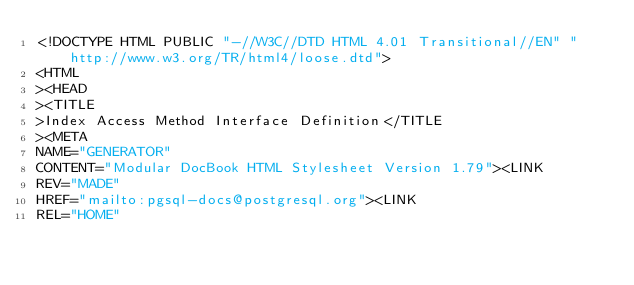<code> <loc_0><loc_0><loc_500><loc_500><_HTML_><!DOCTYPE HTML PUBLIC "-//W3C//DTD HTML 4.01 Transitional//EN" "http://www.w3.org/TR/html4/loose.dtd">
<HTML
><HEAD
><TITLE
>Index Access Method Interface Definition</TITLE
><META
NAME="GENERATOR"
CONTENT="Modular DocBook HTML Stylesheet Version 1.79"><LINK
REV="MADE"
HREF="mailto:pgsql-docs@postgresql.org"><LINK
REL="HOME"</code> 